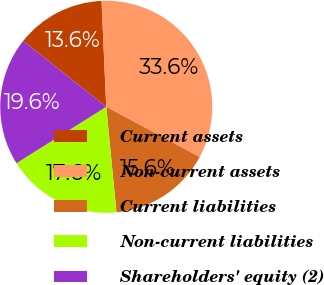<chart> <loc_0><loc_0><loc_500><loc_500><pie_chart><fcel>Current assets<fcel>Non-current assets<fcel>Current liabilities<fcel>Non-current liabilities<fcel>Shareholders' equity (2)<nl><fcel>13.62%<fcel>33.56%<fcel>15.61%<fcel>17.61%<fcel>19.6%<nl></chart> 